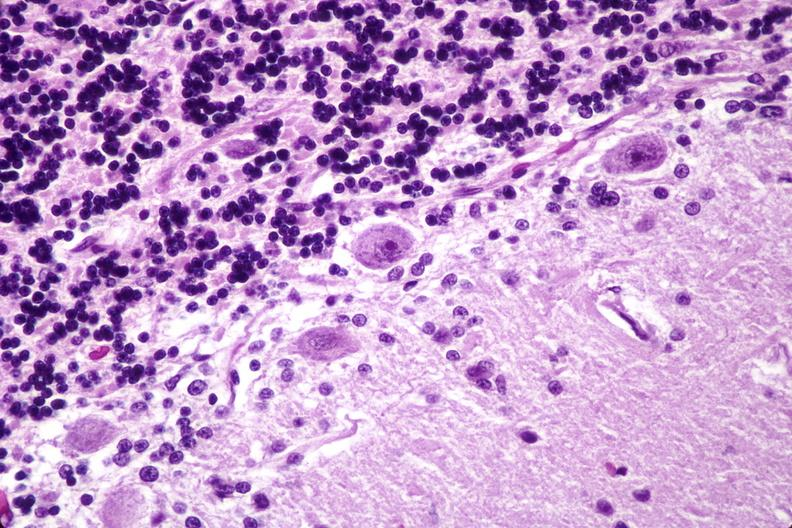s oil acid present?
Answer the question using a single word or phrase. No 